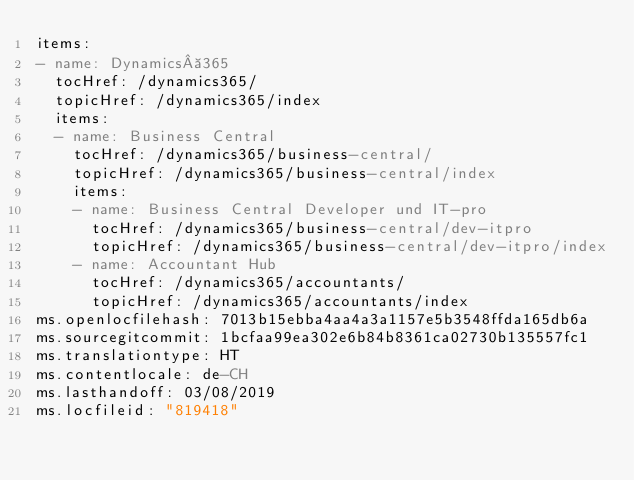<code> <loc_0><loc_0><loc_500><loc_500><_YAML_>items:
- name: Dynamics 365
  tocHref: /dynamics365/
  topicHref: /dynamics365/index
  items:
  - name: Business Central
    tocHref: /dynamics365/business-central/
    topicHref: /dynamics365/business-central/index
    items:
    - name: Business Central Developer und IT-pro
      tocHref: /dynamics365/business-central/dev-itpro
      topicHref: /dynamics365/business-central/dev-itpro/index
    - name: Accountant Hub
      tocHref: /dynamics365/accountants/
      topicHref: /dynamics365/accountants/index
ms.openlocfilehash: 7013b15ebba4aa4a3a1157e5b3548ffda165db6a
ms.sourcegitcommit: 1bcfaa99ea302e6b84b8361ca02730b135557fc1
ms.translationtype: HT
ms.contentlocale: de-CH
ms.lasthandoff: 03/08/2019
ms.locfileid: "819418"
</code> 